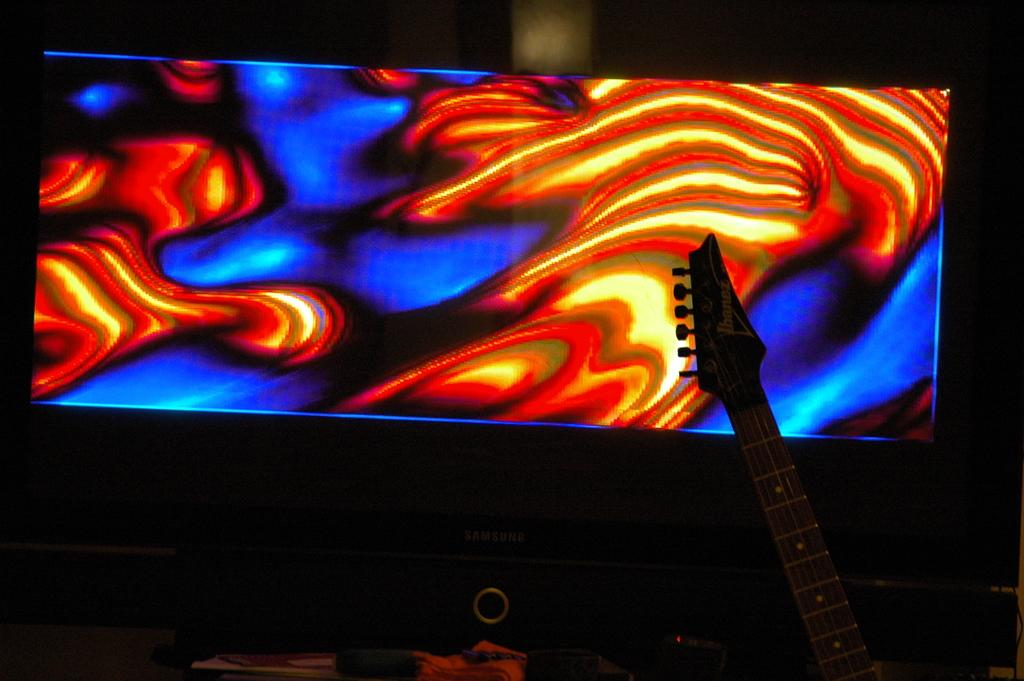What is the main object in the image? There is a monitor screen in the image. What is displayed on the monitor screen? Art is displayed on the monitor screen. Can you describe the colors used in the art? The art contains red and blue colors. What else can be seen in the image? There is a stand for a musical instrument in the right corner of the image. How many square pans are visible on the monitor screen? There are no square pans visible on the monitor screen; it displays art with red and blue colors. 